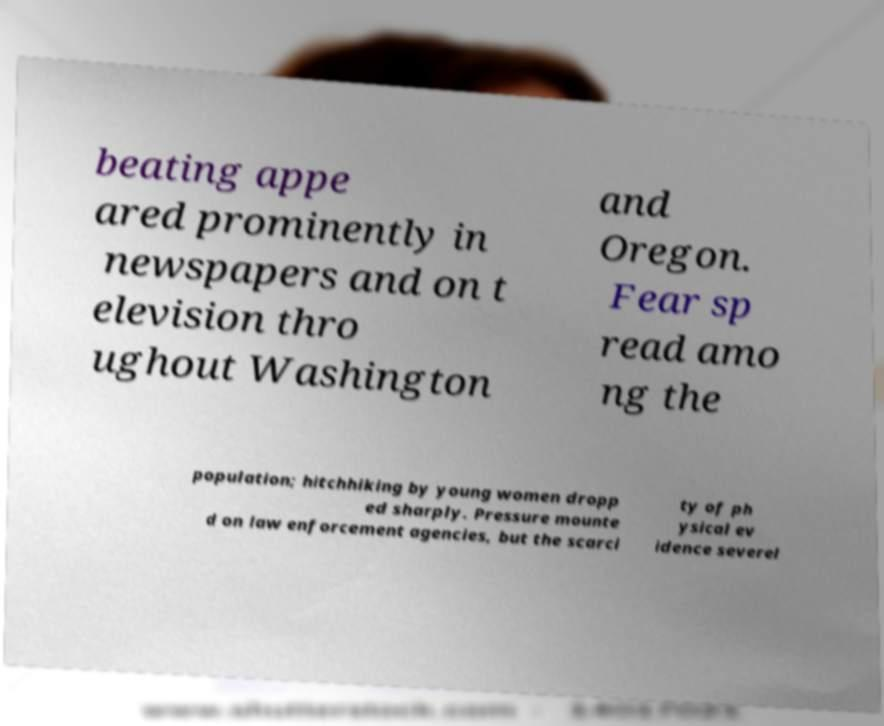What messages or text are displayed in this image? I need them in a readable, typed format. beating appe ared prominently in newspapers and on t elevision thro ughout Washington and Oregon. Fear sp read amo ng the population; hitchhiking by young women dropp ed sharply. Pressure mounte d on law enforcement agencies, but the scarci ty of ph ysical ev idence severel 